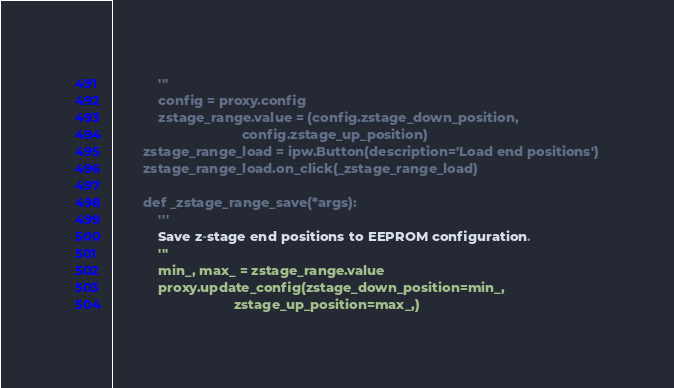Convert code to text. <code><loc_0><loc_0><loc_500><loc_500><_Python_>            '''
            config = proxy.config
            zstage_range.value = (config.zstage_down_position,
                                  config.zstage_up_position)
        zstage_range_load = ipw.Button(description='Load end positions')
        zstage_range_load.on_click(_zstage_range_load)

        def _zstage_range_save(*args):
            '''
            Save z-stage end positions to EEPROM configuration.
            '''
            min_, max_ = zstage_range.value
            proxy.update_config(zstage_down_position=min_,
                                zstage_up_position=max_,)</code> 